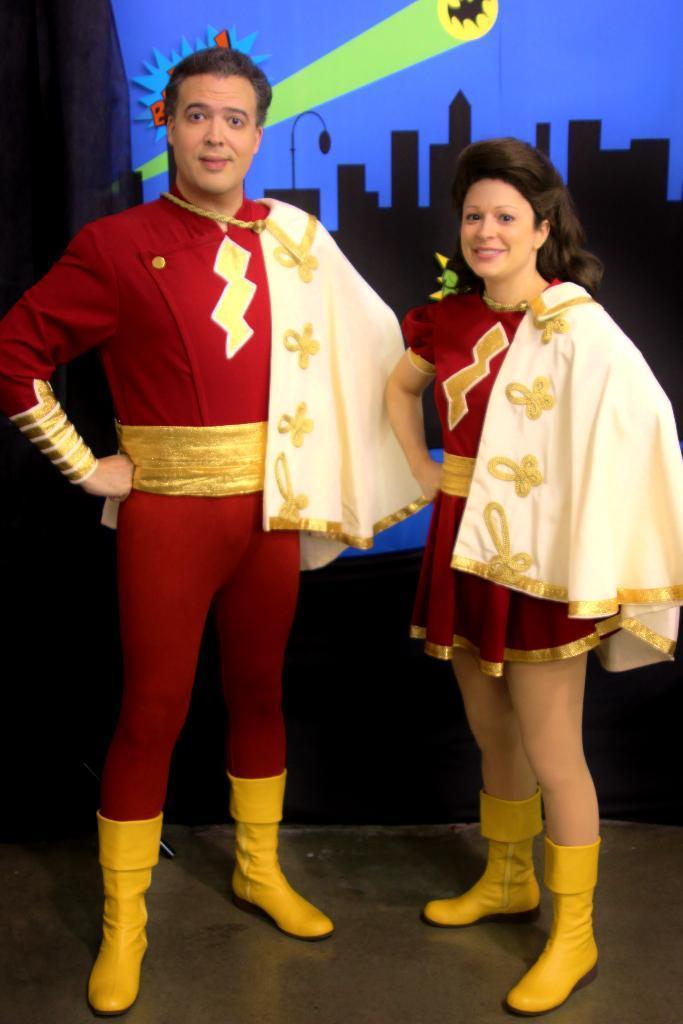Can you describe this image briefly? In this picture we can see 2 people wearing red costumes looking and smiling at someone. 